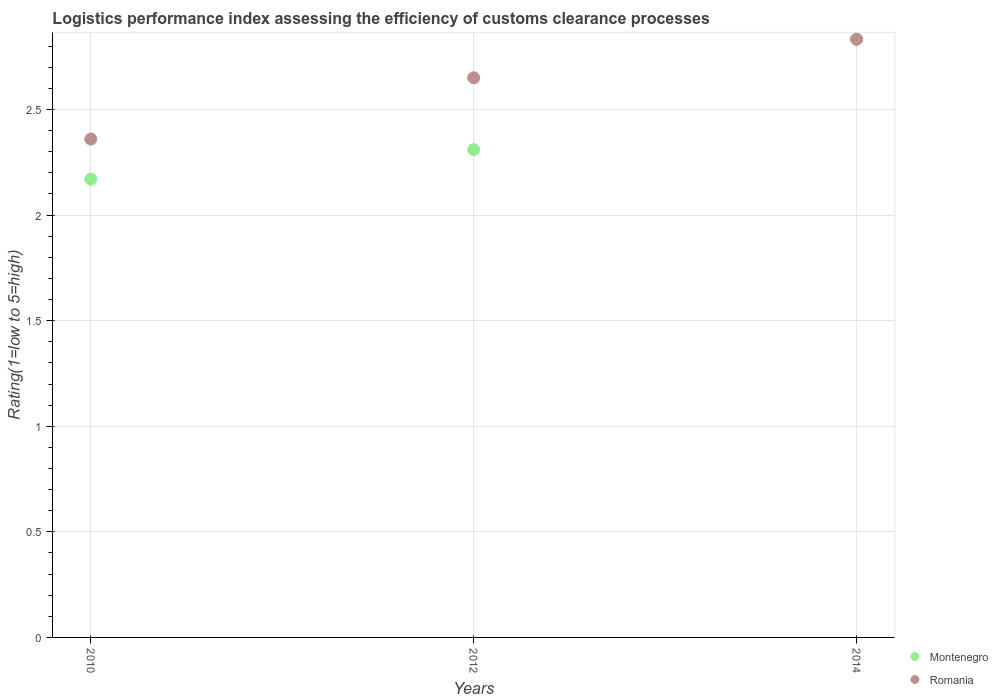How many different coloured dotlines are there?
Provide a short and direct response. 2. Is the number of dotlines equal to the number of legend labels?
Ensure brevity in your answer.  Yes. What is the Logistic performance index in Montenegro in 2010?
Your response must be concise. 2.17. Across all years, what is the maximum Logistic performance index in Montenegro?
Keep it short and to the point. 2.83. Across all years, what is the minimum Logistic performance index in Romania?
Offer a very short reply. 2.36. What is the total Logistic performance index in Romania in the graph?
Your answer should be compact. 7.84. What is the difference between the Logistic performance index in Montenegro in 2010 and that in 2014?
Your answer should be compact. -0.66. What is the difference between the Logistic performance index in Romania in 2014 and the Logistic performance index in Montenegro in 2012?
Ensure brevity in your answer.  0.52. What is the average Logistic performance index in Montenegro per year?
Make the answer very short. 2.44. In the year 2014, what is the difference between the Logistic performance index in Romania and Logistic performance index in Montenegro?
Ensure brevity in your answer.  0. In how many years, is the Logistic performance index in Montenegro greater than 2.1?
Offer a terse response. 3. What is the ratio of the Logistic performance index in Romania in 2010 to that in 2012?
Your response must be concise. 0.89. Is the Logistic performance index in Romania in 2012 less than that in 2014?
Make the answer very short. Yes. What is the difference between the highest and the second highest Logistic performance index in Romania?
Keep it short and to the point. 0.18. What is the difference between the highest and the lowest Logistic performance index in Romania?
Provide a short and direct response. 0.47. Is the sum of the Logistic performance index in Montenegro in 2010 and 2014 greater than the maximum Logistic performance index in Romania across all years?
Your answer should be very brief. Yes. Does the Logistic performance index in Montenegro monotonically increase over the years?
Give a very brief answer. Yes. Is the Logistic performance index in Romania strictly greater than the Logistic performance index in Montenegro over the years?
Your answer should be compact. Yes. Is the Logistic performance index in Montenegro strictly less than the Logistic performance index in Romania over the years?
Give a very brief answer. Yes. How many dotlines are there?
Make the answer very short. 2. Does the graph contain any zero values?
Keep it short and to the point. No. Does the graph contain grids?
Give a very brief answer. Yes. How are the legend labels stacked?
Offer a terse response. Vertical. What is the title of the graph?
Give a very brief answer. Logistics performance index assessing the efficiency of customs clearance processes. Does "Finland" appear as one of the legend labels in the graph?
Your answer should be very brief. No. What is the label or title of the Y-axis?
Give a very brief answer. Rating(1=low to 5=high). What is the Rating(1=low to 5=high) of Montenegro in 2010?
Your response must be concise. 2.17. What is the Rating(1=low to 5=high) in Romania in 2010?
Offer a very short reply. 2.36. What is the Rating(1=low to 5=high) of Montenegro in 2012?
Provide a short and direct response. 2.31. What is the Rating(1=low to 5=high) of Romania in 2012?
Keep it short and to the point. 2.65. What is the Rating(1=low to 5=high) in Montenegro in 2014?
Offer a terse response. 2.83. What is the Rating(1=low to 5=high) of Romania in 2014?
Ensure brevity in your answer.  2.83. Across all years, what is the maximum Rating(1=low to 5=high) of Montenegro?
Your answer should be very brief. 2.83. Across all years, what is the maximum Rating(1=low to 5=high) in Romania?
Make the answer very short. 2.83. Across all years, what is the minimum Rating(1=low to 5=high) of Montenegro?
Your answer should be very brief. 2.17. Across all years, what is the minimum Rating(1=low to 5=high) in Romania?
Give a very brief answer. 2.36. What is the total Rating(1=low to 5=high) of Montenegro in the graph?
Make the answer very short. 7.31. What is the total Rating(1=low to 5=high) of Romania in the graph?
Ensure brevity in your answer.  7.84. What is the difference between the Rating(1=low to 5=high) in Montenegro in 2010 and that in 2012?
Your answer should be very brief. -0.14. What is the difference between the Rating(1=low to 5=high) in Romania in 2010 and that in 2012?
Your answer should be compact. -0.29. What is the difference between the Rating(1=low to 5=high) in Montenegro in 2010 and that in 2014?
Offer a terse response. -0.66. What is the difference between the Rating(1=low to 5=high) in Romania in 2010 and that in 2014?
Offer a very short reply. -0.47. What is the difference between the Rating(1=low to 5=high) of Montenegro in 2012 and that in 2014?
Offer a very short reply. -0.52. What is the difference between the Rating(1=low to 5=high) of Romania in 2012 and that in 2014?
Your answer should be very brief. -0.18. What is the difference between the Rating(1=low to 5=high) of Montenegro in 2010 and the Rating(1=low to 5=high) of Romania in 2012?
Your response must be concise. -0.48. What is the difference between the Rating(1=low to 5=high) in Montenegro in 2010 and the Rating(1=low to 5=high) in Romania in 2014?
Provide a succinct answer. -0.66. What is the difference between the Rating(1=low to 5=high) of Montenegro in 2012 and the Rating(1=low to 5=high) of Romania in 2014?
Offer a very short reply. -0.52. What is the average Rating(1=low to 5=high) of Montenegro per year?
Make the answer very short. 2.44. What is the average Rating(1=low to 5=high) of Romania per year?
Provide a short and direct response. 2.61. In the year 2010, what is the difference between the Rating(1=low to 5=high) of Montenegro and Rating(1=low to 5=high) of Romania?
Offer a very short reply. -0.19. In the year 2012, what is the difference between the Rating(1=low to 5=high) in Montenegro and Rating(1=low to 5=high) in Romania?
Your answer should be very brief. -0.34. In the year 2014, what is the difference between the Rating(1=low to 5=high) in Montenegro and Rating(1=low to 5=high) in Romania?
Provide a succinct answer. -0. What is the ratio of the Rating(1=low to 5=high) in Montenegro in 2010 to that in 2012?
Your response must be concise. 0.94. What is the ratio of the Rating(1=low to 5=high) in Romania in 2010 to that in 2012?
Your response must be concise. 0.89. What is the ratio of the Rating(1=low to 5=high) in Montenegro in 2010 to that in 2014?
Offer a terse response. 0.77. What is the ratio of the Rating(1=low to 5=high) in Romania in 2010 to that in 2014?
Your answer should be compact. 0.83. What is the ratio of the Rating(1=low to 5=high) of Montenegro in 2012 to that in 2014?
Your answer should be very brief. 0.82. What is the ratio of the Rating(1=low to 5=high) of Romania in 2012 to that in 2014?
Give a very brief answer. 0.94. What is the difference between the highest and the second highest Rating(1=low to 5=high) in Montenegro?
Offer a terse response. 0.52. What is the difference between the highest and the second highest Rating(1=low to 5=high) in Romania?
Offer a terse response. 0.18. What is the difference between the highest and the lowest Rating(1=low to 5=high) in Montenegro?
Give a very brief answer. 0.66. What is the difference between the highest and the lowest Rating(1=low to 5=high) of Romania?
Provide a short and direct response. 0.47. 